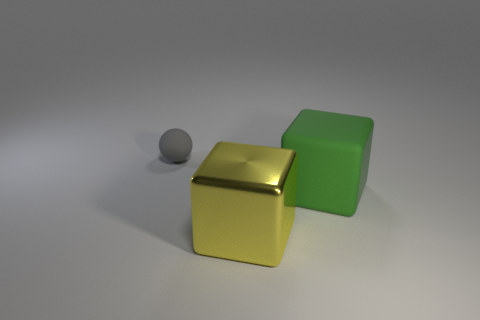How many objects are things that are in front of the big green cube or big shiny things?
Make the answer very short. 1. Is the number of gray matte balls that are on the right side of the big green rubber cube the same as the number of big red shiny cubes?
Your answer should be very brief. Yes. Do the yellow thing and the gray rubber sphere have the same size?
Make the answer very short. No. What is the color of the block that is the same size as the green matte thing?
Your answer should be very brief. Yellow. There is a gray object; does it have the same size as the matte object that is in front of the ball?
Give a very brief answer. No. What number of big shiny blocks are the same color as the tiny ball?
Provide a short and direct response. 0. How many things are big gray rubber things or objects in front of the small matte object?
Offer a terse response. 2. There is a matte thing that is to the right of the matte sphere; is its size the same as the matte object behind the green rubber cube?
Provide a succinct answer. No. Is there a yellow sphere made of the same material as the tiny gray thing?
Provide a succinct answer. No. The large yellow object is what shape?
Your answer should be very brief. Cube. 